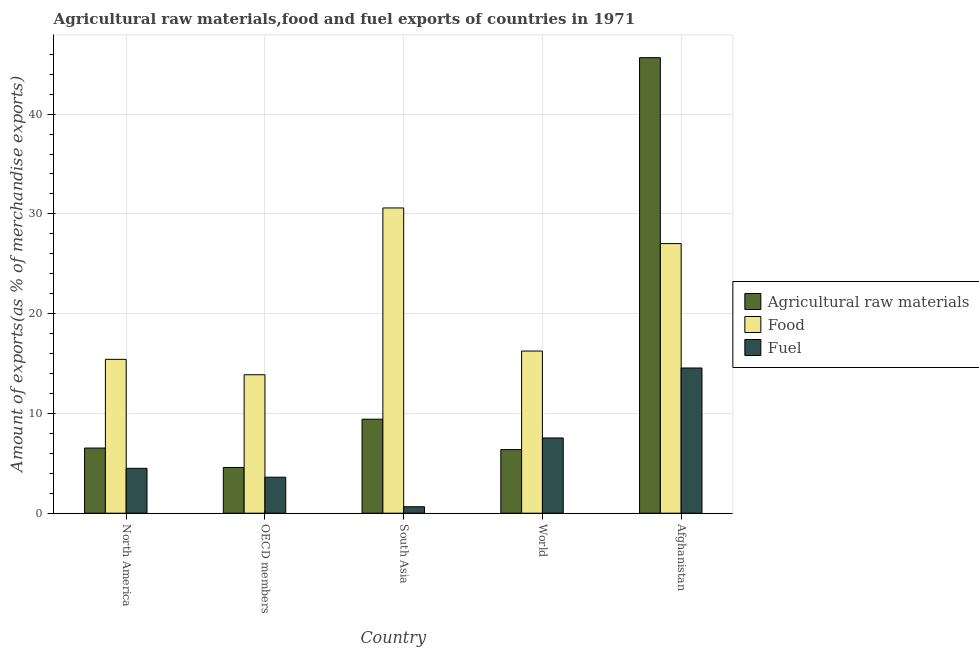How many different coloured bars are there?
Provide a short and direct response. 3. Are the number of bars per tick equal to the number of legend labels?
Offer a very short reply. Yes. How many bars are there on the 3rd tick from the right?
Give a very brief answer. 3. In how many cases, is the number of bars for a given country not equal to the number of legend labels?
Make the answer very short. 0. What is the percentage of raw materials exports in Afghanistan?
Give a very brief answer. 45.66. Across all countries, what is the maximum percentage of fuel exports?
Offer a very short reply. 14.55. Across all countries, what is the minimum percentage of food exports?
Provide a short and direct response. 13.88. In which country was the percentage of raw materials exports maximum?
Provide a short and direct response. Afghanistan. In which country was the percentage of food exports minimum?
Offer a terse response. OECD members. What is the total percentage of food exports in the graph?
Give a very brief answer. 103.17. What is the difference between the percentage of raw materials exports in North America and that in OECD members?
Provide a succinct answer. 1.94. What is the difference between the percentage of food exports in South Asia and the percentage of fuel exports in North America?
Your response must be concise. 26.1. What is the average percentage of food exports per country?
Your answer should be very brief. 20.63. What is the difference between the percentage of food exports and percentage of fuel exports in Afghanistan?
Ensure brevity in your answer.  12.47. What is the ratio of the percentage of food exports in Afghanistan to that in North America?
Keep it short and to the point. 1.75. What is the difference between the highest and the second highest percentage of raw materials exports?
Offer a terse response. 36.23. What is the difference between the highest and the lowest percentage of fuel exports?
Your response must be concise. 13.91. What does the 1st bar from the left in World represents?
Offer a very short reply. Agricultural raw materials. What does the 1st bar from the right in OECD members represents?
Your response must be concise. Fuel. Is it the case that in every country, the sum of the percentage of raw materials exports and percentage of food exports is greater than the percentage of fuel exports?
Your response must be concise. Yes. How many bars are there?
Give a very brief answer. 15. Are all the bars in the graph horizontal?
Provide a short and direct response. No. How many countries are there in the graph?
Keep it short and to the point. 5. What is the difference between two consecutive major ticks on the Y-axis?
Provide a short and direct response. 10. Are the values on the major ticks of Y-axis written in scientific E-notation?
Your answer should be very brief. No. Does the graph contain grids?
Your response must be concise. Yes. Where does the legend appear in the graph?
Provide a succinct answer. Center right. What is the title of the graph?
Make the answer very short. Agricultural raw materials,food and fuel exports of countries in 1971. What is the label or title of the Y-axis?
Make the answer very short. Amount of exports(as % of merchandise exports). What is the Amount of exports(as % of merchandise exports) of Agricultural raw materials in North America?
Your answer should be compact. 6.53. What is the Amount of exports(as % of merchandise exports) of Food in North America?
Make the answer very short. 15.42. What is the Amount of exports(as % of merchandise exports) in Fuel in North America?
Your answer should be compact. 4.5. What is the Amount of exports(as % of merchandise exports) of Agricultural raw materials in OECD members?
Keep it short and to the point. 4.58. What is the Amount of exports(as % of merchandise exports) in Food in OECD members?
Keep it short and to the point. 13.88. What is the Amount of exports(as % of merchandise exports) of Fuel in OECD members?
Your answer should be very brief. 3.61. What is the Amount of exports(as % of merchandise exports) in Agricultural raw materials in South Asia?
Ensure brevity in your answer.  9.42. What is the Amount of exports(as % of merchandise exports) of Food in South Asia?
Provide a succinct answer. 30.59. What is the Amount of exports(as % of merchandise exports) of Fuel in South Asia?
Keep it short and to the point. 0.65. What is the Amount of exports(as % of merchandise exports) in Agricultural raw materials in World?
Ensure brevity in your answer.  6.37. What is the Amount of exports(as % of merchandise exports) of Food in World?
Offer a very short reply. 16.25. What is the Amount of exports(as % of merchandise exports) of Fuel in World?
Provide a succinct answer. 7.54. What is the Amount of exports(as % of merchandise exports) of Agricultural raw materials in Afghanistan?
Ensure brevity in your answer.  45.66. What is the Amount of exports(as % of merchandise exports) in Food in Afghanistan?
Give a very brief answer. 27.02. What is the Amount of exports(as % of merchandise exports) in Fuel in Afghanistan?
Provide a succinct answer. 14.55. Across all countries, what is the maximum Amount of exports(as % of merchandise exports) in Agricultural raw materials?
Provide a succinct answer. 45.66. Across all countries, what is the maximum Amount of exports(as % of merchandise exports) of Food?
Give a very brief answer. 30.59. Across all countries, what is the maximum Amount of exports(as % of merchandise exports) in Fuel?
Offer a terse response. 14.55. Across all countries, what is the minimum Amount of exports(as % of merchandise exports) in Agricultural raw materials?
Offer a terse response. 4.58. Across all countries, what is the minimum Amount of exports(as % of merchandise exports) in Food?
Keep it short and to the point. 13.88. Across all countries, what is the minimum Amount of exports(as % of merchandise exports) of Fuel?
Your answer should be compact. 0.65. What is the total Amount of exports(as % of merchandise exports) of Agricultural raw materials in the graph?
Offer a terse response. 72.56. What is the total Amount of exports(as % of merchandise exports) of Food in the graph?
Your answer should be compact. 103.17. What is the total Amount of exports(as % of merchandise exports) in Fuel in the graph?
Offer a very short reply. 30.85. What is the difference between the Amount of exports(as % of merchandise exports) of Agricultural raw materials in North America and that in OECD members?
Give a very brief answer. 1.94. What is the difference between the Amount of exports(as % of merchandise exports) in Food in North America and that in OECD members?
Offer a terse response. 1.54. What is the difference between the Amount of exports(as % of merchandise exports) of Fuel in North America and that in OECD members?
Your answer should be very brief. 0.89. What is the difference between the Amount of exports(as % of merchandise exports) in Agricultural raw materials in North America and that in South Asia?
Offer a terse response. -2.89. What is the difference between the Amount of exports(as % of merchandise exports) of Food in North America and that in South Asia?
Provide a succinct answer. -15.17. What is the difference between the Amount of exports(as % of merchandise exports) of Fuel in North America and that in South Asia?
Make the answer very short. 3.85. What is the difference between the Amount of exports(as % of merchandise exports) in Agricultural raw materials in North America and that in World?
Make the answer very short. 0.15. What is the difference between the Amount of exports(as % of merchandise exports) in Food in North America and that in World?
Keep it short and to the point. -0.83. What is the difference between the Amount of exports(as % of merchandise exports) in Fuel in North America and that in World?
Provide a short and direct response. -3.04. What is the difference between the Amount of exports(as % of merchandise exports) of Agricultural raw materials in North America and that in Afghanistan?
Your answer should be compact. -39.13. What is the difference between the Amount of exports(as % of merchandise exports) of Food in North America and that in Afghanistan?
Make the answer very short. -11.6. What is the difference between the Amount of exports(as % of merchandise exports) of Fuel in North America and that in Afghanistan?
Make the answer very short. -10.05. What is the difference between the Amount of exports(as % of merchandise exports) in Agricultural raw materials in OECD members and that in South Asia?
Keep it short and to the point. -4.84. What is the difference between the Amount of exports(as % of merchandise exports) in Food in OECD members and that in South Asia?
Provide a succinct answer. -16.72. What is the difference between the Amount of exports(as % of merchandise exports) in Fuel in OECD members and that in South Asia?
Provide a short and direct response. 2.96. What is the difference between the Amount of exports(as % of merchandise exports) in Agricultural raw materials in OECD members and that in World?
Offer a terse response. -1.79. What is the difference between the Amount of exports(as % of merchandise exports) in Food in OECD members and that in World?
Offer a very short reply. -2.37. What is the difference between the Amount of exports(as % of merchandise exports) of Fuel in OECD members and that in World?
Offer a very short reply. -3.93. What is the difference between the Amount of exports(as % of merchandise exports) of Agricultural raw materials in OECD members and that in Afghanistan?
Give a very brief answer. -41.07. What is the difference between the Amount of exports(as % of merchandise exports) of Food in OECD members and that in Afghanistan?
Ensure brevity in your answer.  -13.14. What is the difference between the Amount of exports(as % of merchandise exports) of Fuel in OECD members and that in Afghanistan?
Give a very brief answer. -10.94. What is the difference between the Amount of exports(as % of merchandise exports) of Agricultural raw materials in South Asia and that in World?
Your answer should be compact. 3.05. What is the difference between the Amount of exports(as % of merchandise exports) in Food in South Asia and that in World?
Give a very brief answer. 14.34. What is the difference between the Amount of exports(as % of merchandise exports) of Fuel in South Asia and that in World?
Offer a terse response. -6.89. What is the difference between the Amount of exports(as % of merchandise exports) of Agricultural raw materials in South Asia and that in Afghanistan?
Give a very brief answer. -36.23. What is the difference between the Amount of exports(as % of merchandise exports) in Food in South Asia and that in Afghanistan?
Your answer should be very brief. 3.57. What is the difference between the Amount of exports(as % of merchandise exports) in Fuel in South Asia and that in Afghanistan?
Make the answer very short. -13.91. What is the difference between the Amount of exports(as % of merchandise exports) in Agricultural raw materials in World and that in Afghanistan?
Your response must be concise. -39.28. What is the difference between the Amount of exports(as % of merchandise exports) in Food in World and that in Afghanistan?
Offer a terse response. -10.77. What is the difference between the Amount of exports(as % of merchandise exports) in Fuel in World and that in Afghanistan?
Provide a short and direct response. -7.01. What is the difference between the Amount of exports(as % of merchandise exports) in Agricultural raw materials in North America and the Amount of exports(as % of merchandise exports) in Food in OECD members?
Give a very brief answer. -7.35. What is the difference between the Amount of exports(as % of merchandise exports) of Agricultural raw materials in North America and the Amount of exports(as % of merchandise exports) of Fuel in OECD members?
Make the answer very short. 2.92. What is the difference between the Amount of exports(as % of merchandise exports) in Food in North America and the Amount of exports(as % of merchandise exports) in Fuel in OECD members?
Keep it short and to the point. 11.81. What is the difference between the Amount of exports(as % of merchandise exports) of Agricultural raw materials in North America and the Amount of exports(as % of merchandise exports) of Food in South Asia?
Your answer should be very brief. -24.07. What is the difference between the Amount of exports(as % of merchandise exports) of Agricultural raw materials in North America and the Amount of exports(as % of merchandise exports) of Fuel in South Asia?
Offer a terse response. 5.88. What is the difference between the Amount of exports(as % of merchandise exports) in Food in North America and the Amount of exports(as % of merchandise exports) in Fuel in South Asia?
Offer a terse response. 14.77. What is the difference between the Amount of exports(as % of merchandise exports) in Agricultural raw materials in North America and the Amount of exports(as % of merchandise exports) in Food in World?
Your response must be concise. -9.72. What is the difference between the Amount of exports(as % of merchandise exports) in Agricultural raw materials in North America and the Amount of exports(as % of merchandise exports) in Fuel in World?
Your answer should be compact. -1.01. What is the difference between the Amount of exports(as % of merchandise exports) of Food in North America and the Amount of exports(as % of merchandise exports) of Fuel in World?
Offer a terse response. 7.88. What is the difference between the Amount of exports(as % of merchandise exports) of Agricultural raw materials in North America and the Amount of exports(as % of merchandise exports) of Food in Afghanistan?
Give a very brief answer. -20.49. What is the difference between the Amount of exports(as % of merchandise exports) in Agricultural raw materials in North America and the Amount of exports(as % of merchandise exports) in Fuel in Afghanistan?
Ensure brevity in your answer.  -8.02. What is the difference between the Amount of exports(as % of merchandise exports) in Food in North America and the Amount of exports(as % of merchandise exports) in Fuel in Afghanistan?
Keep it short and to the point. 0.87. What is the difference between the Amount of exports(as % of merchandise exports) in Agricultural raw materials in OECD members and the Amount of exports(as % of merchandise exports) in Food in South Asia?
Your answer should be very brief. -26.01. What is the difference between the Amount of exports(as % of merchandise exports) in Agricultural raw materials in OECD members and the Amount of exports(as % of merchandise exports) in Fuel in South Asia?
Your answer should be very brief. 3.94. What is the difference between the Amount of exports(as % of merchandise exports) in Food in OECD members and the Amount of exports(as % of merchandise exports) in Fuel in South Asia?
Your response must be concise. 13.23. What is the difference between the Amount of exports(as % of merchandise exports) in Agricultural raw materials in OECD members and the Amount of exports(as % of merchandise exports) in Food in World?
Make the answer very short. -11.67. What is the difference between the Amount of exports(as % of merchandise exports) in Agricultural raw materials in OECD members and the Amount of exports(as % of merchandise exports) in Fuel in World?
Provide a succinct answer. -2.96. What is the difference between the Amount of exports(as % of merchandise exports) in Food in OECD members and the Amount of exports(as % of merchandise exports) in Fuel in World?
Offer a very short reply. 6.34. What is the difference between the Amount of exports(as % of merchandise exports) of Agricultural raw materials in OECD members and the Amount of exports(as % of merchandise exports) of Food in Afghanistan?
Your answer should be compact. -22.44. What is the difference between the Amount of exports(as % of merchandise exports) in Agricultural raw materials in OECD members and the Amount of exports(as % of merchandise exports) in Fuel in Afghanistan?
Make the answer very short. -9.97. What is the difference between the Amount of exports(as % of merchandise exports) of Food in OECD members and the Amount of exports(as % of merchandise exports) of Fuel in Afghanistan?
Offer a very short reply. -0.68. What is the difference between the Amount of exports(as % of merchandise exports) of Agricultural raw materials in South Asia and the Amount of exports(as % of merchandise exports) of Food in World?
Offer a very short reply. -6.83. What is the difference between the Amount of exports(as % of merchandise exports) of Agricultural raw materials in South Asia and the Amount of exports(as % of merchandise exports) of Fuel in World?
Your response must be concise. 1.88. What is the difference between the Amount of exports(as % of merchandise exports) in Food in South Asia and the Amount of exports(as % of merchandise exports) in Fuel in World?
Ensure brevity in your answer.  23.05. What is the difference between the Amount of exports(as % of merchandise exports) in Agricultural raw materials in South Asia and the Amount of exports(as % of merchandise exports) in Food in Afghanistan?
Give a very brief answer. -17.6. What is the difference between the Amount of exports(as % of merchandise exports) in Agricultural raw materials in South Asia and the Amount of exports(as % of merchandise exports) in Fuel in Afghanistan?
Offer a terse response. -5.13. What is the difference between the Amount of exports(as % of merchandise exports) in Food in South Asia and the Amount of exports(as % of merchandise exports) in Fuel in Afghanistan?
Provide a short and direct response. 16.04. What is the difference between the Amount of exports(as % of merchandise exports) of Agricultural raw materials in World and the Amount of exports(as % of merchandise exports) of Food in Afghanistan?
Offer a very short reply. -20.65. What is the difference between the Amount of exports(as % of merchandise exports) of Agricultural raw materials in World and the Amount of exports(as % of merchandise exports) of Fuel in Afghanistan?
Ensure brevity in your answer.  -8.18. What is the difference between the Amount of exports(as % of merchandise exports) of Food in World and the Amount of exports(as % of merchandise exports) of Fuel in Afghanistan?
Your answer should be compact. 1.7. What is the average Amount of exports(as % of merchandise exports) in Agricultural raw materials per country?
Keep it short and to the point. 14.51. What is the average Amount of exports(as % of merchandise exports) in Food per country?
Offer a terse response. 20.63. What is the average Amount of exports(as % of merchandise exports) in Fuel per country?
Your response must be concise. 6.17. What is the difference between the Amount of exports(as % of merchandise exports) in Agricultural raw materials and Amount of exports(as % of merchandise exports) in Food in North America?
Make the answer very short. -8.89. What is the difference between the Amount of exports(as % of merchandise exports) in Agricultural raw materials and Amount of exports(as % of merchandise exports) in Fuel in North America?
Ensure brevity in your answer.  2.03. What is the difference between the Amount of exports(as % of merchandise exports) of Food and Amount of exports(as % of merchandise exports) of Fuel in North America?
Provide a short and direct response. 10.92. What is the difference between the Amount of exports(as % of merchandise exports) of Agricultural raw materials and Amount of exports(as % of merchandise exports) of Food in OECD members?
Your response must be concise. -9.29. What is the difference between the Amount of exports(as % of merchandise exports) of Agricultural raw materials and Amount of exports(as % of merchandise exports) of Fuel in OECD members?
Make the answer very short. 0.97. What is the difference between the Amount of exports(as % of merchandise exports) of Food and Amount of exports(as % of merchandise exports) of Fuel in OECD members?
Keep it short and to the point. 10.27. What is the difference between the Amount of exports(as % of merchandise exports) in Agricultural raw materials and Amount of exports(as % of merchandise exports) in Food in South Asia?
Provide a short and direct response. -21.17. What is the difference between the Amount of exports(as % of merchandise exports) in Agricultural raw materials and Amount of exports(as % of merchandise exports) in Fuel in South Asia?
Your response must be concise. 8.77. What is the difference between the Amount of exports(as % of merchandise exports) of Food and Amount of exports(as % of merchandise exports) of Fuel in South Asia?
Make the answer very short. 29.95. What is the difference between the Amount of exports(as % of merchandise exports) of Agricultural raw materials and Amount of exports(as % of merchandise exports) of Food in World?
Your response must be concise. -9.88. What is the difference between the Amount of exports(as % of merchandise exports) in Agricultural raw materials and Amount of exports(as % of merchandise exports) in Fuel in World?
Your response must be concise. -1.17. What is the difference between the Amount of exports(as % of merchandise exports) in Food and Amount of exports(as % of merchandise exports) in Fuel in World?
Ensure brevity in your answer.  8.71. What is the difference between the Amount of exports(as % of merchandise exports) of Agricultural raw materials and Amount of exports(as % of merchandise exports) of Food in Afghanistan?
Ensure brevity in your answer.  18.64. What is the difference between the Amount of exports(as % of merchandise exports) of Agricultural raw materials and Amount of exports(as % of merchandise exports) of Fuel in Afghanistan?
Provide a succinct answer. 31.1. What is the difference between the Amount of exports(as % of merchandise exports) in Food and Amount of exports(as % of merchandise exports) in Fuel in Afghanistan?
Keep it short and to the point. 12.47. What is the ratio of the Amount of exports(as % of merchandise exports) in Agricultural raw materials in North America to that in OECD members?
Give a very brief answer. 1.42. What is the ratio of the Amount of exports(as % of merchandise exports) in Food in North America to that in OECD members?
Offer a terse response. 1.11. What is the ratio of the Amount of exports(as % of merchandise exports) of Fuel in North America to that in OECD members?
Ensure brevity in your answer.  1.25. What is the ratio of the Amount of exports(as % of merchandise exports) in Agricultural raw materials in North America to that in South Asia?
Your response must be concise. 0.69. What is the ratio of the Amount of exports(as % of merchandise exports) in Food in North America to that in South Asia?
Your answer should be compact. 0.5. What is the ratio of the Amount of exports(as % of merchandise exports) of Fuel in North America to that in South Asia?
Make the answer very short. 6.95. What is the ratio of the Amount of exports(as % of merchandise exports) in Agricultural raw materials in North America to that in World?
Your answer should be compact. 1.02. What is the ratio of the Amount of exports(as % of merchandise exports) in Food in North America to that in World?
Offer a very short reply. 0.95. What is the ratio of the Amount of exports(as % of merchandise exports) in Fuel in North America to that in World?
Provide a short and direct response. 0.6. What is the ratio of the Amount of exports(as % of merchandise exports) in Agricultural raw materials in North America to that in Afghanistan?
Offer a very short reply. 0.14. What is the ratio of the Amount of exports(as % of merchandise exports) in Food in North America to that in Afghanistan?
Give a very brief answer. 0.57. What is the ratio of the Amount of exports(as % of merchandise exports) of Fuel in North America to that in Afghanistan?
Give a very brief answer. 0.31. What is the ratio of the Amount of exports(as % of merchandise exports) in Agricultural raw materials in OECD members to that in South Asia?
Ensure brevity in your answer.  0.49. What is the ratio of the Amount of exports(as % of merchandise exports) in Food in OECD members to that in South Asia?
Provide a succinct answer. 0.45. What is the ratio of the Amount of exports(as % of merchandise exports) of Fuel in OECD members to that in South Asia?
Give a very brief answer. 5.57. What is the ratio of the Amount of exports(as % of merchandise exports) of Agricultural raw materials in OECD members to that in World?
Ensure brevity in your answer.  0.72. What is the ratio of the Amount of exports(as % of merchandise exports) in Food in OECD members to that in World?
Your answer should be very brief. 0.85. What is the ratio of the Amount of exports(as % of merchandise exports) of Fuel in OECD members to that in World?
Keep it short and to the point. 0.48. What is the ratio of the Amount of exports(as % of merchandise exports) in Agricultural raw materials in OECD members to that in Afghanistan?
Keep it short and to the point. 0.1. What is the ratio of the Amount of exports(as % of merchandise exports) of Food in OECD members to that in Afghanistan?
Provide a succinct answer. 0.51. What is the ratio of the Amount of exports(as % of merchandise exports) in Fuel in OECD members to that in Afghanistan?
Provide a succinct answer. 0.25. What is the ratio of the Amount of exports(as % of merchandise exports) of Agricultural raw materials in South Asia to that in World?
Give a very brief answer. 1.48. What is the ratio of the Amount of exports(as % of merchandise exports) in Food in South Asia to that in World?
Your response must be concise. 1.88. What is the ratio of the Amount of exports(as % of merchandise exports) in Fuel in South Asia to that in World?
Give a very brief answer. 0.09. What is the ratio of the Amount of exports(as % of merchandise exports) in Agricultural raw materials in South Asia to that in Afghanistan?
Give a very brief answer. 0.21. What is the ratio of the Amount of exports(as % of merchandise exports) of Food in South Asia to that in Afghanistan?
Offer a terse response. 1.13. What is the ratio of the Amount of exports(as % of merchandise exports) in Fuel in South Asia to that in Afghanistan?
Ensure brevity in your answer.  0.04. What is the ratio of the Amount of exports(as % of merchandise exports) of Agricultural raw materials in World to that in Afghanistan?
Give a very brief answer. 0.14. What is the ratio of the Amount of exports(as % of merchandise exports) in Food in World to that in Afghanistan?
Your answer should be very brief. 0.6. What is the ratio of the Amount of exports(as % of merchandise exports) of Fuel in World to that in Afghanistan?
Make the answer very short. 0.52. What is the difference between the highest and the second highest Amount of exports(as % of merchandise exports) in Agricultural raw materials?
Your response must be concise. 36.23. What is the difference between the highest and the second highest Amount of exports(as % of merchandise exports) in Food?
Give a very brief answer. 3.57. What is the difference between the highest and the second highest Amount of exports(as % of merchandise exports) of Fuel?
Your response must be concise. 7.01. What is the difference between the highest and the lowest Amount of exports(as % of merchandise exports) of Agricultural raw materials?
Provide a short and direct response. 41.07. What is the difference between the highest and the lowest Amount of exports(as % of merchandise exports) in Food?
Ensure brevity in your answer.  16.72. What is the difference between the highest and the lowest Amount of exports(as % of merchandise exports) in Fuel?
Provide a short and direct response. 13.91. 